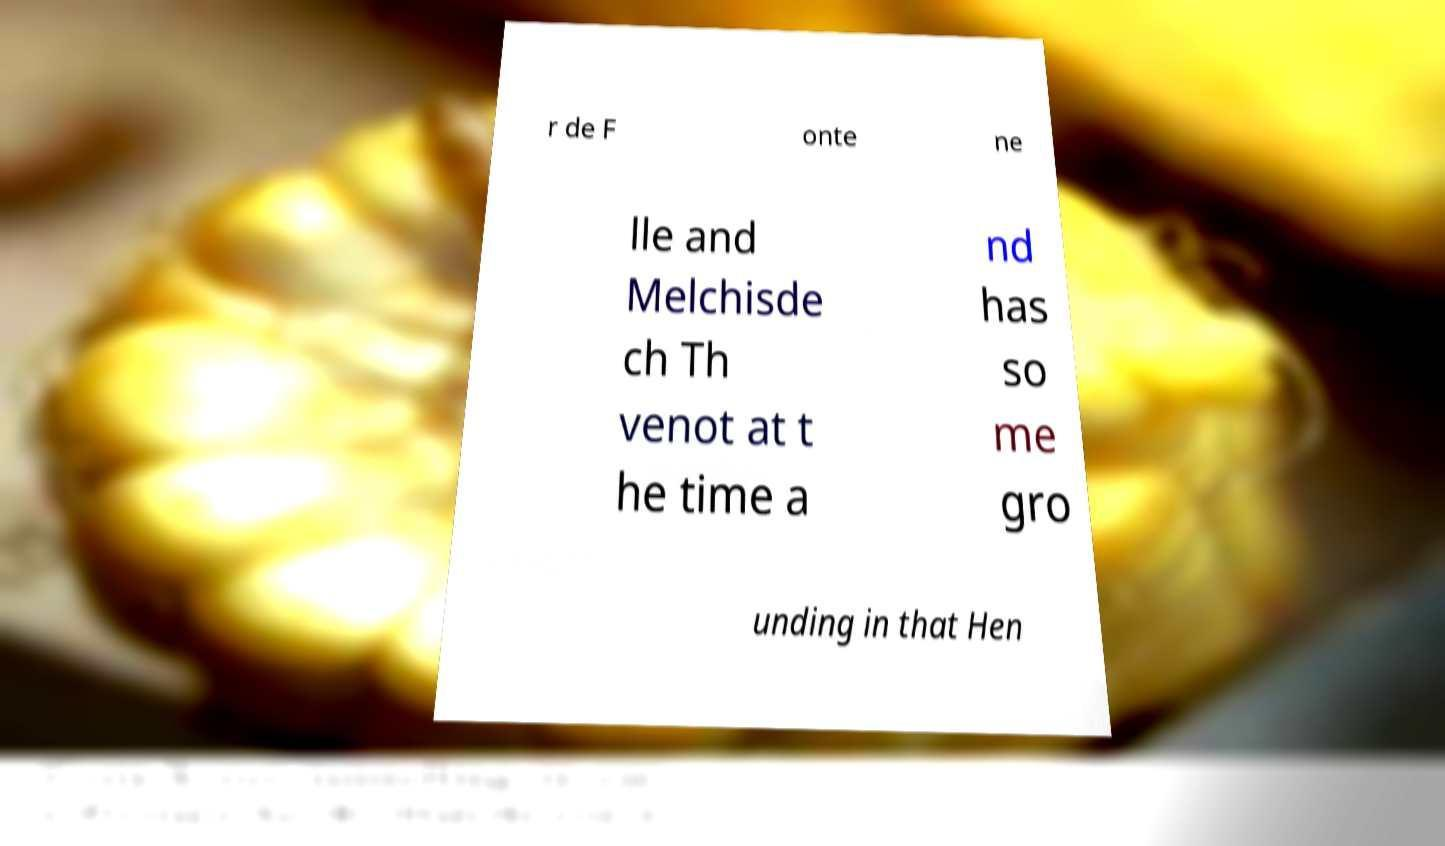Can you read and provide the text displayed in the image?This photo seems to have some interesting text. Can you extract and type it out for me? r de F onte ne lle and Melchisde ch Th venot at t he time a nd has so me gro unding in that Hen 